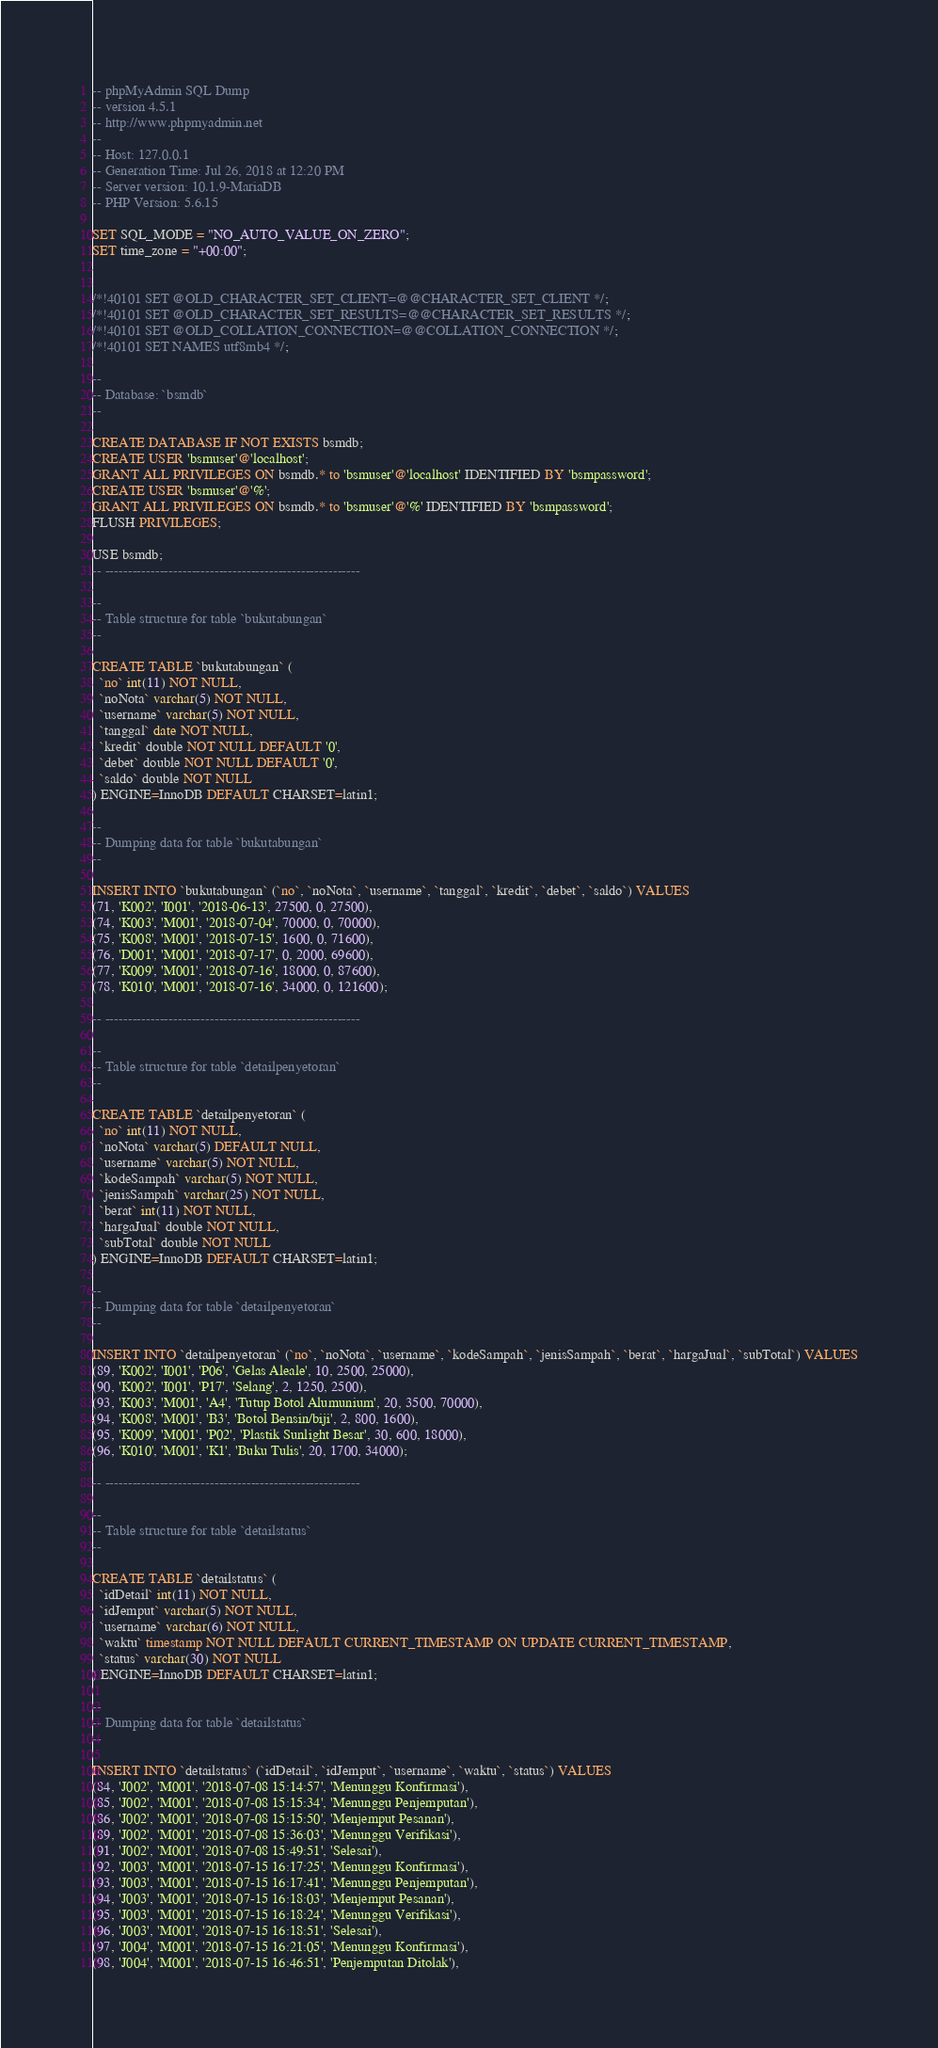Convert code to text. <code><loc_0><loc_0><loc_500><loc_500><_SQL_>-- phpMyAdmin SQL Dump
-- version 4.5.1
-- http://www.phpmyadmin.net
--
-- Host: 127.0.0.1
-- Generation Time: Jul 26, 2018 at 12:20 PM
-- Server version: 10.1.9-MariaDB
-- PHP Version: 5.6.15

SET SQL_MODE = "NO_AUTO_VALUE_ON_ZERO";
SET time_zone = "+00:00";


/*!40101 SET @OLD_CHARACTER_SET_CLIENT=@@CHARACTER_SET_CLIENT */;
/*!40101 SET @OLD_CHARACTER_SET_RESULTS=@@CHARACTER_SET_RESULTS */;
/*!40101 SET @OLD_COLLATION_CONNECTION=@@COLLATION_CONNECTION */;
/*!40101 SET NAMES utf8mb4 */;

--
-- Database: `bsmdb`
--

CREATE DATABASE IF NOT EXISTS bsmdb;
CREATE USER 'bsmuser'@'localhost'; 
GRANT ALL PRIVILEGES ON bsmdb.* to 'bsmuser'@'localhost' IDENTIFIED BY 'bsmpassword'; 
CREATE USER 'bsmuser'@'%'; 
GRANT ALL PRIVILEGES ON bsmdb.* to 'bsmuser'@'%' IDENTIFIED BY 'bsmpassword'; 
FLUSH PRIVILEGES;

USE bsmdb;
-- --------------------------------------------------------

--
-- Table structure for table `bukutabungan`
--

CREATE TABLE `bukutabungan` (
  `no` int(11) NOT NULL,
  `noNota` varchar(5) NOT NULL,
  `username` varchar(5) NOT NULL,
  `tanggal` date NOT NULL,
  `kredit` double NOT NULL DEFAULT '0',
  `debet` double NOT NULL DEFAULT '0',
  `saldo` double NOT NULL
) ENGINE=InnoDB DEFAULT CHARSET=latin1;

--
-- Dumping data for table `bukutabungan`
--

INSERT INTO `bukutabungan` (`no`, `noNota`, `username`, `tanggal`, `kredit`, `debet`, `saldo`) VALUES
(71, 'K002', 'I001', '2018-06-13', 27500, 0, 27500),
(74, 'K003', 'M001', '2018-07-04', 70000, 0, 70000),
(75, 'K008', 'M001', '2018-07-15', 1600, 0, 71600),
(76, 'D001', 'M001', '2018-07-17', 0, 2000, 69600),
(77, 'K009', 'M001', '2018-07-16', 18000, 0, 87600),
(78, 'K010', 'M001', '2018-07-16', 34000, 0, 121600);

-- --------------------------------------------------------

--
-- Table structure for table `detailpenyetoran`
--

CREATE TABLE `detailpenyetoran` (
  `no` int(11) NOT NULL,
  `noNota` varchar(5) DEFAULT NULL,
  `username` varchar(5) NOT NULL,
  `kodeSampah` varchar(5) NOT NULL,
  `jenisSampah` varchar(25) NOT NULL,
  `berat` int(11) NOT NULL,
  `hargaJual` double NOT NULL,
  `subTotal` double NOT NULL
) ENGINE=InnoDB DEFAULT CHARSET=latin1;

--
-- Dumping data for table `detailpenyetoran`
--

INSERT INTO `detailpenyetoran` (`no`, `noNota`, `username`, `kodeSampah`, `jenisSampah`, `berat`, `hargaJual`, `subTotal`) VALUES
(89, 'K002', 'I001', 'P06', 'Gelas Aleale', 10, 2500, 25000),
(90, 'K002', 'I001', 'P17', 'Selang', 2, 1250, 2500),
(93, 'K003', 'M001', 'A4', 'Tutup Botol Alumunium', 20, 3500, 70000),
(94, 'K008', 'M001', 'B3', 'Botol Bensin/biji', 2, 800, 1600),
(95, 'K009', 'M001', 'P02', 'Plastik Sunlight Besar', 30, 600, 18000),
(96, 'K010', 'M001', 'K1', 'Buku Tulis', 20, 1700, 34000);

-- --------------------------------------------------------

--
-- Table structure for table `detailstatus`
--

CREATE TABLE `detailstatus` (
  `idDetail` int(11) NOT NULL,
  `idJemput` varchar(5) NOT NULL,
  `username` varchar(6) NOT NULL,
  `waktu` timestamp NOT NULL DEFAULT CURRENT_TIMESTAMP ON UPDATE CURRENT_TIMESTAMP,
  `status` varchar(30) NOT NULL
) ENGINE=InnoDB DEFAULT CHARSET=latin1;

--
-- Dumping data for table `detailstatus`
--

INSERT INTO `detailstatus` (`idDetail`, `idJemput`, `username`, `waktu`, `status`) VALUES
(84, 'J002', 'M001', '2018-07-08 15:14:57', 'Menunggu Konfirmasi'),
(85, 'J002', 'M001', '2018-07-08 15:15:34', 'Menunggu Penjemputan'),
(86, 'J002', 'M001', '2018-07-08 15:15:50', 'Menjemput Pesanan'),
(89, 'J002', 'M001', '2018-07-08 15:36:03', 'Menunggu Verifikasi'),
(91, 'J002', 'M001', '2018-07-08 15:49:51', 'Selesai'),
(92, 'J003', 'M001', '2018-07-15 16:17:25', 'Menunggu Konfirmasi'),
(93, 'J003', 'M001', '2018-07-15 16:17:41', 'Menunggu Penjemputan'),
(94, 'J003', 'M001', '2018-07-15 16:18:03', 'Menjemput Pesanan'),
(95, 'J003', 'M001', '2018-07-15 16:18:24', 'Menunggu Verifikasi'),
(96, 'J003', 'M001', '2018-07-15 16:18:51', 'Selesai'),
(97, 'J004', 'M001', '2018-07-15 16:21:05', 'Menunggu Konfirmasi'),
(98, 'J004', 'M001', '2018-07-15 16:46:51', 'Penjemputan Ditolak'),</code> 